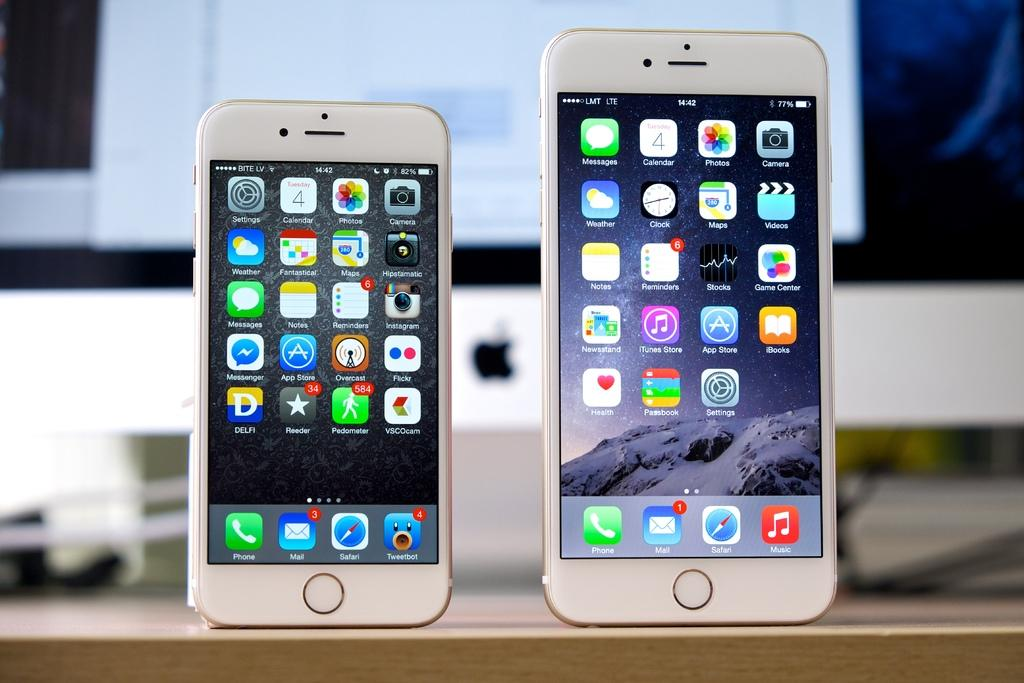Provide a one-sentence caption for the provided image. Two devices next to each other, the bigger one says LMT LTE in the corner. 